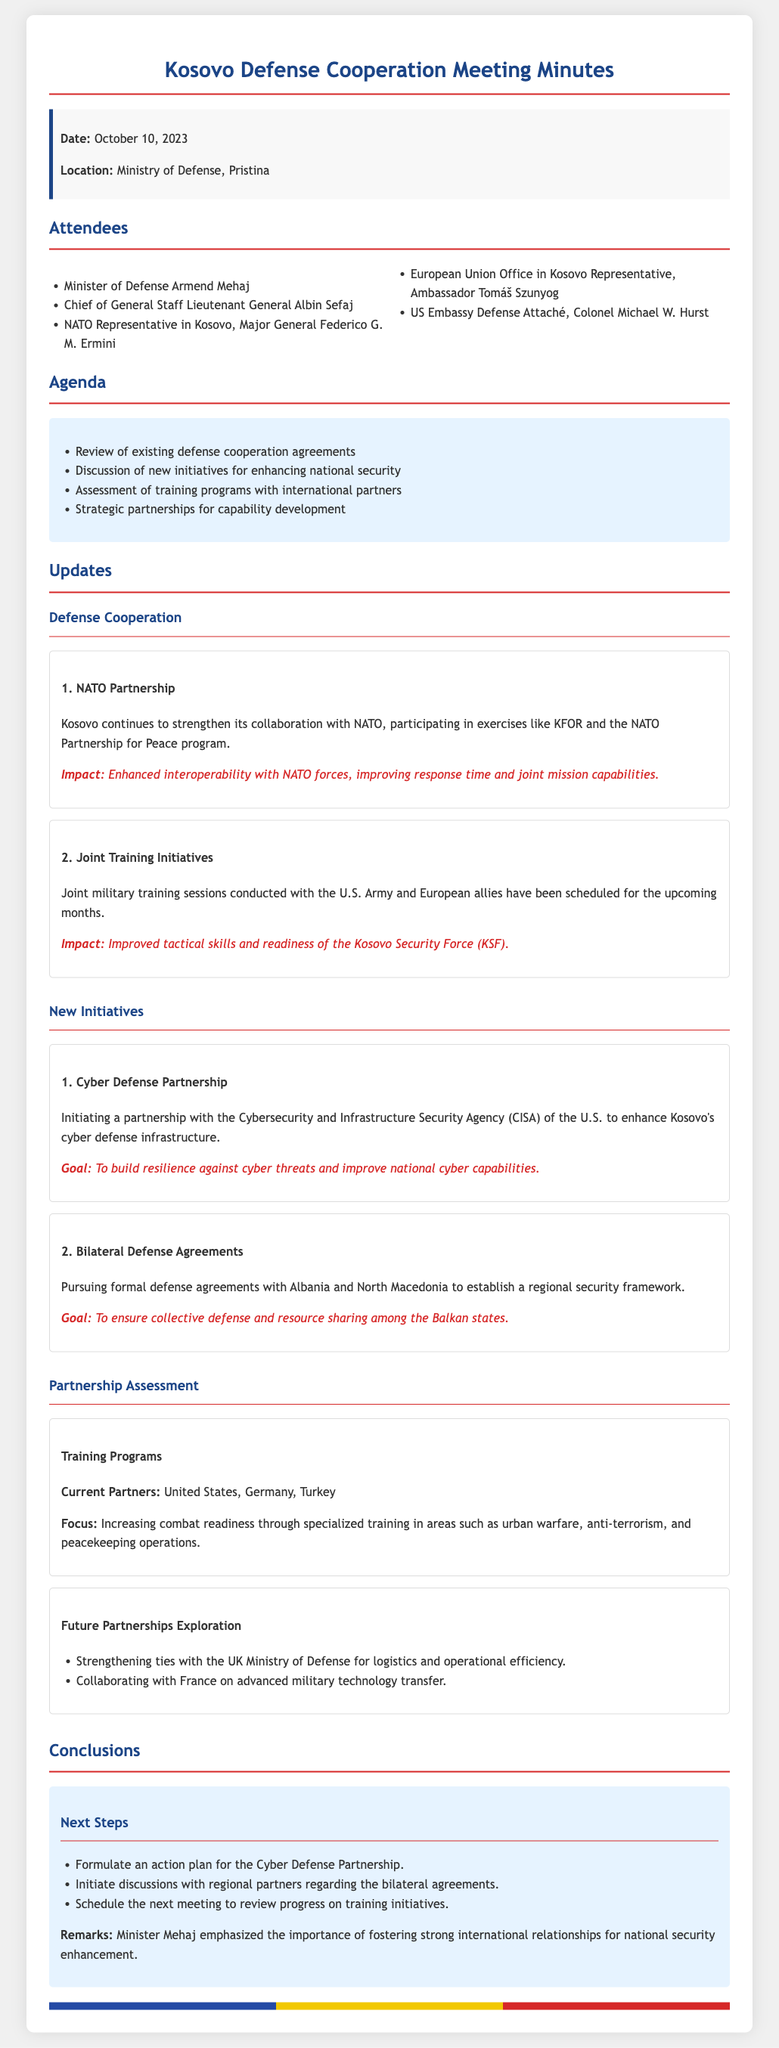What is the date of the meeting? The date of the meeting is stated in the header information of the document.
Answer: October 10, 2023 Who is the Minister of Defense? The name of the Minister of Defense is listed among the attendees in the document.
Answer: Armend Mehaj What is one of the main goals of the Cyber Defense Partnership? The document explicitly states the goal associated with the Cyber Defense Partnership.
Answer: To build resilience against cyber threats Which countries are involved in pursuing bilateral defense agreements? The document lists the countries involved in bilateral defense agreements under the new initiatives section.
Answer: Albania and North Macedonia How many current partners are mentioned for training programs? The number of current partners is mentioned in the context of training programs.
Answer: Three What military exercise does Kosovo participate in with NATO? The document names a specific NATO exercise that Kosovo is involved in under defense cooperation.
Answer: KFOR What does the document suggest will be a focus of future partnerships? The document outlines specific focus areas for future partnerships.
Answer: Advanced military technology transfer What is emphasized by Minister Mehaj regarding international relationships? The conclusion in the document includes statements made by Minister Mehaj highlighting a particular theme.
Answer: Importance of fostering strong international relationships 